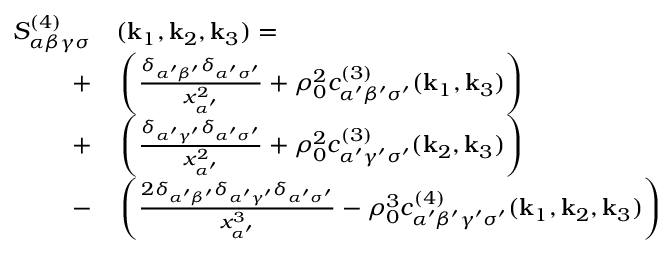<formula> <loc_0><loc_0><loc_500><loc_500>\begin{array} { r l } { S _ { \alpha \beta \gamma \sigma } ^ { ( 4 ) } } & ( k _ { 1 } , k _ { 2 } , k _ { 3 } ) = } \\ { + } & \left ( \frac { \delta _ { \alpha ^ { \prime } \beta ^ { \prime } } \delta _ { \alpha ^ { \prime } \sigma ^ { \prime } } } { x _ { \alpha ^ { \prime } } ^ { 2 } } + \rho _ { 0 } ^ { 2 } c _ { \alpha ^ { \prime } \beta ^ { \prime } \sigma ^ { \prime } } ^ { ( 3 ) } ( k _ { 1 } , k _ { 3 } ) \right ) } \\ { + } & \left ( \frac { \delta _ { \alpha ^ { \prime } \gamma ^ { \prime } } \delta _ { \alpha ^ { \prime } \sigma ^ { \prime } } } { x _ { \alpha ^ { \prime } } ^ { 2 } } + \rho _ { 0 } ^ { 2 } { c } _ { \alpha ^ { \prime } \gamma ^ { \prime } \sigma ^ { \prime } } ^ { ( 3 ) } ( k _ { 2 } , k _ { 3 } ) \right ) } \\ { - } & \left ( \frac { 2 \delta _ { \alpha ^ { \prime } \beta ^ { \prime } } \delta _ { \alpha ^ { \prime } \gamma ^ { \prime } } \delta _ { \alpha ^ { \prime } \sigma ^ { \prime } } } { x _ { \alpha ^ { \prime } } ^ { 3 } } - \rho _ { 0 } ^ { 3 } { c } _ { \alpha ^ { \prime } \beta ^ { \prime } \gamma ^ { \prime } \sigma ^ { \prime } } ^ { ( 4 ) } ( k _ { 1 } , k _ { 2 } , k _ { 3 } ) \right ) } \end{array}</formula> 